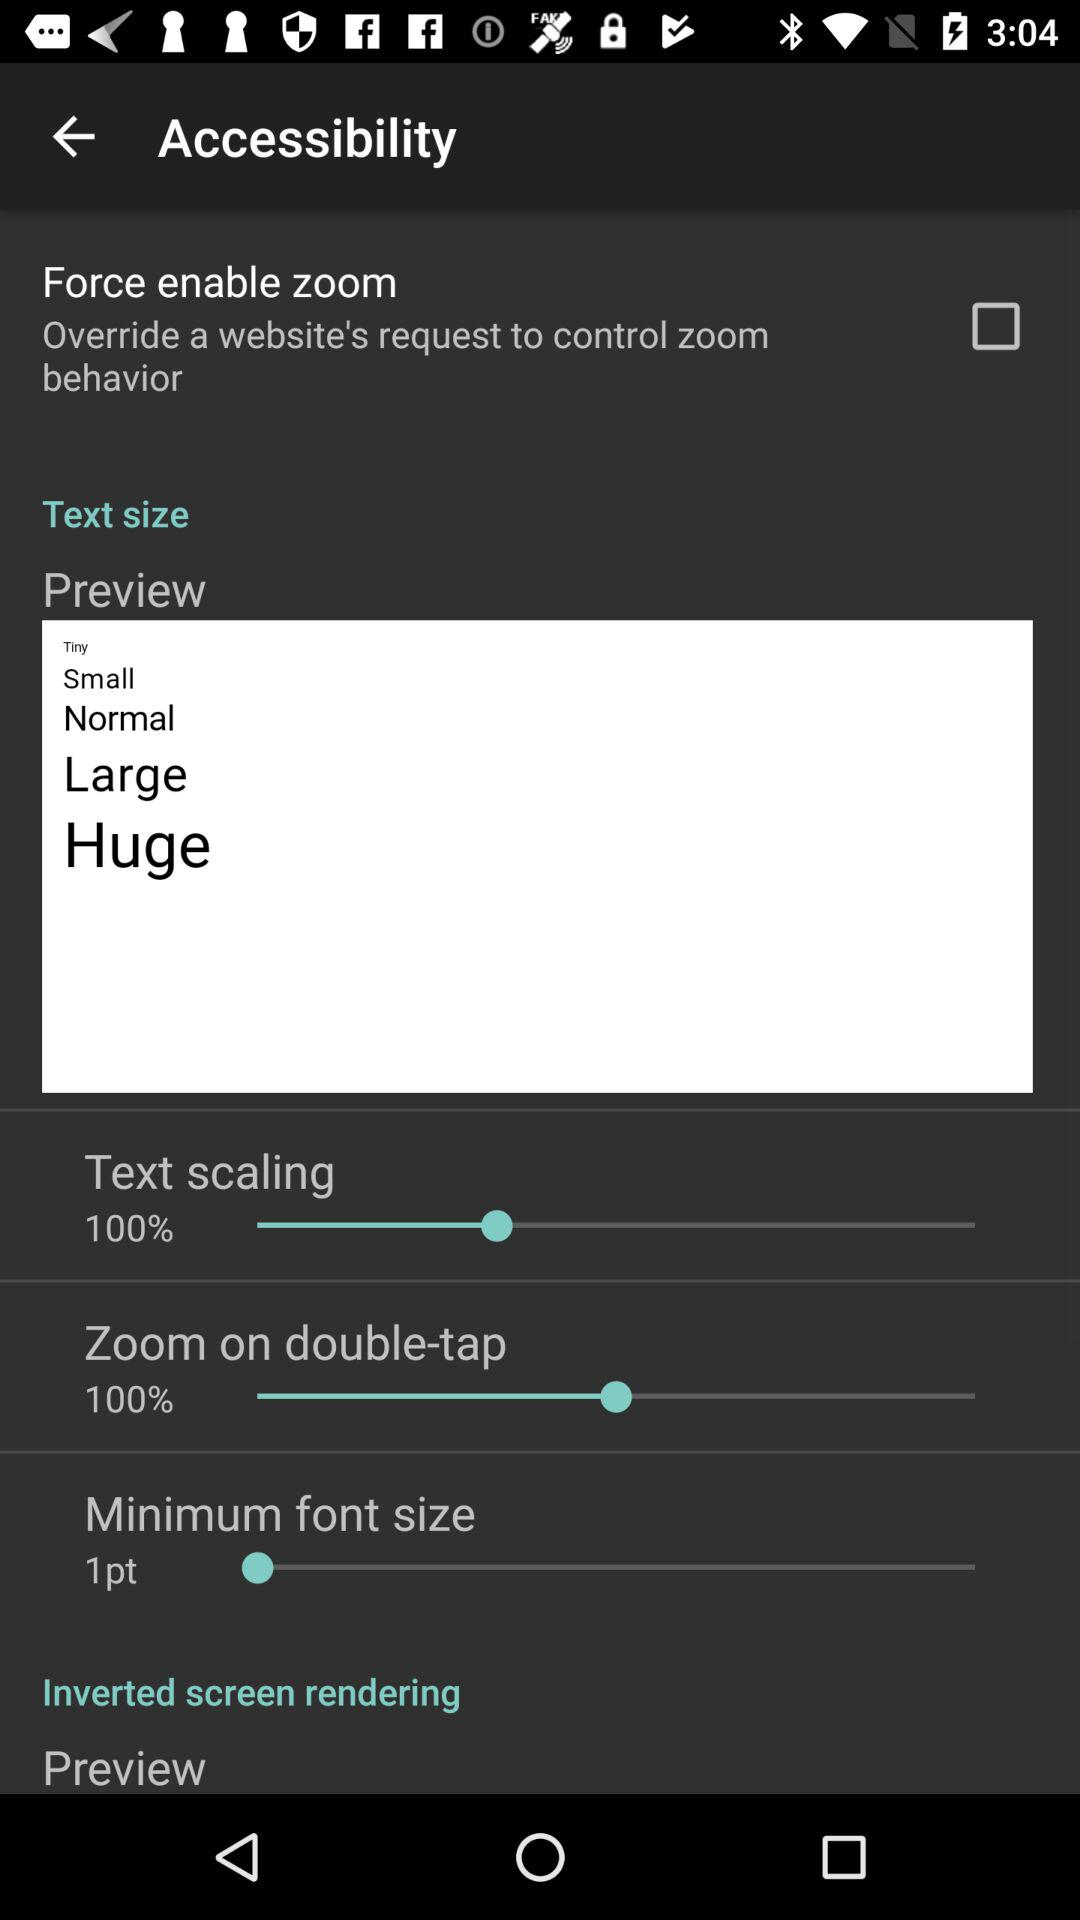What is the minimum font size? The minimum font size is 1pt. 